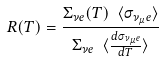<formula> <loc_0><loc_0><loc_500><loc_500>R ( T ) = \frac { \Sigma _ { { \nu } e } ( T ) \ \langle \sigma _ { { \nu _ { \mu } } e } \rangle } { \Sigma _ { { \nu } e } \ \langle \frac { d \sigma _ { { \nu _ { \mu } } e } } { d T } \rangle }</formula> 